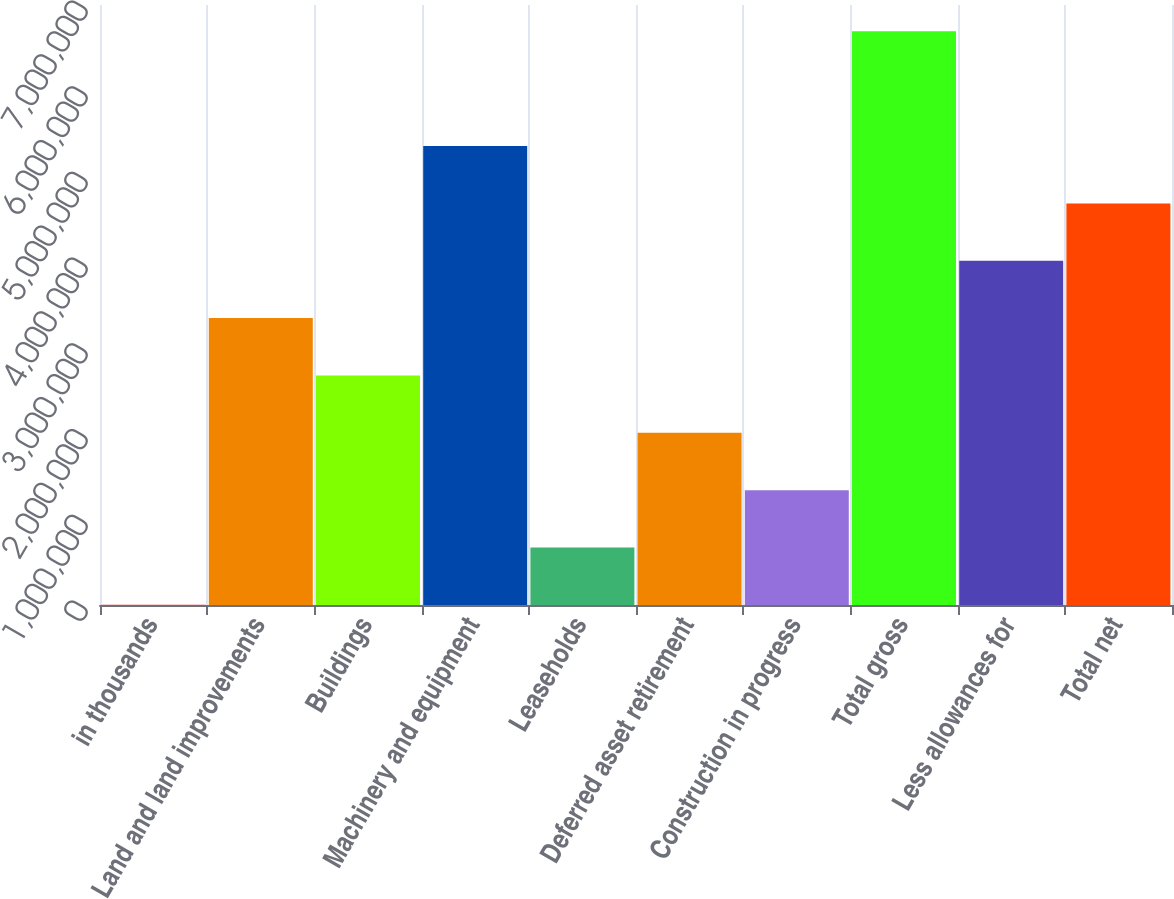<chart> <loc_0><loc_0><loc_500><loc_500><bar_chart><fcel>in thousands<fcel>Land and land improvements<fcel>Buildings<fcel>Machinery and equipment<fcel>Leaseholds<fcel>Deferred asset retirement<fcel>Construction in progress<fcel>Total gross<fcel>Less allowances for<fcel>Total net<nl><fcel>2010<fcel>3.34741e+06<fcel>2.67833e+06<fcel>5.35465e+06<fcel>671090<fcel>2.00925e+06<fcel>1.34017e+06<fcel>6.69281e+06<fcel>4.01649e+06<fcel>4.68557e+06<nl></chart> 